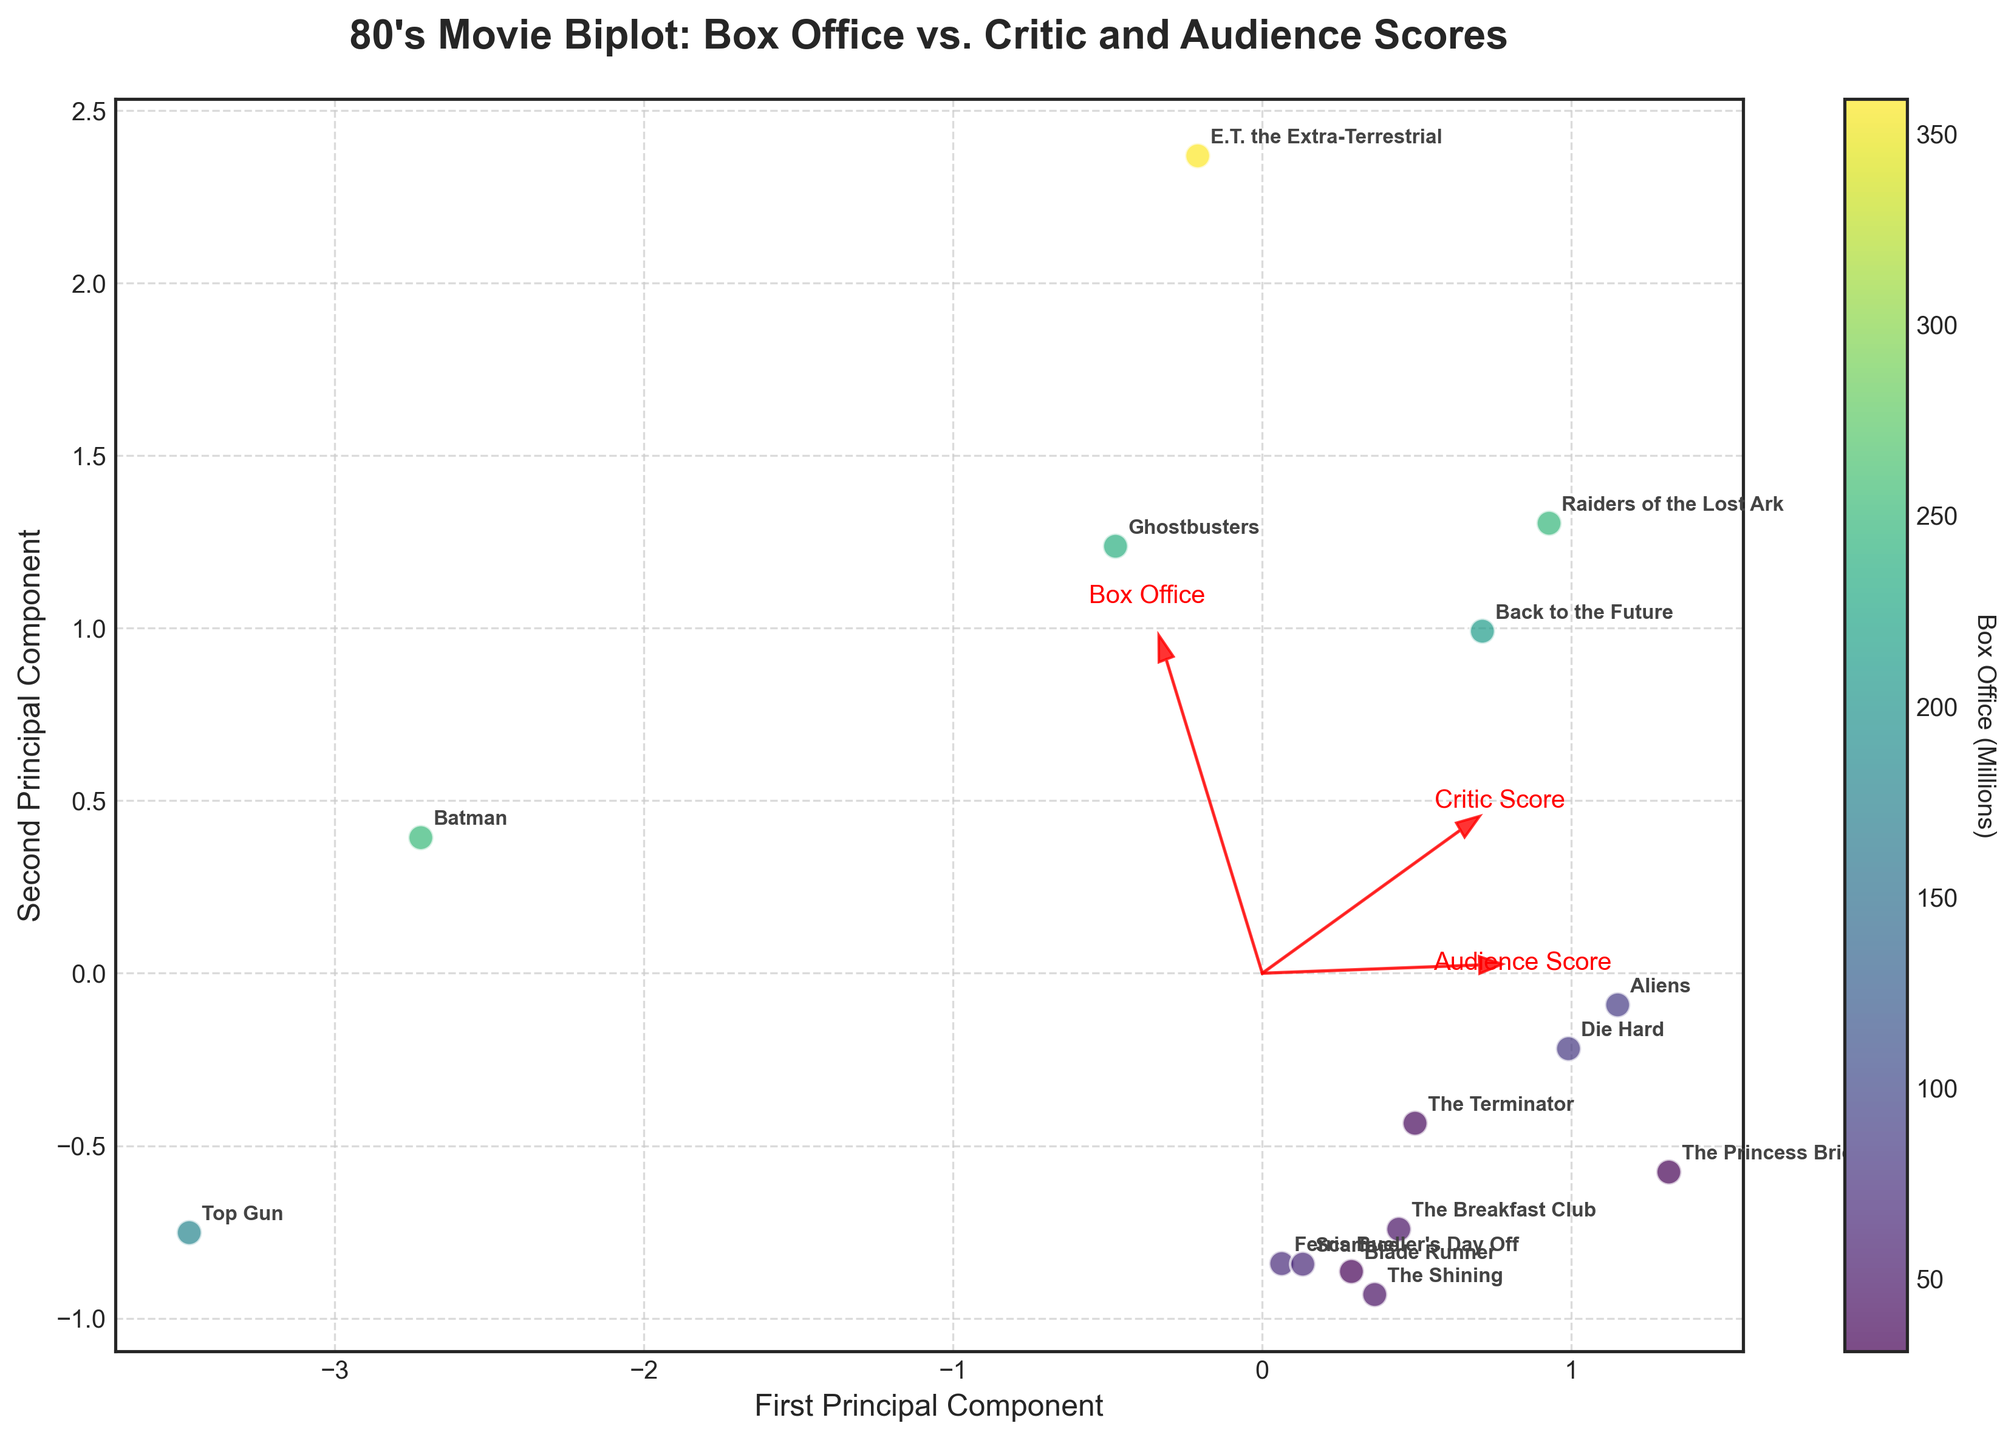What is the title of the plot? The title is usually placed at the top of the plot and gives a brief summary of what the plot represents. Here, the title is "80's Movie Biplot: Box Office vs. Critic and Audience Scores."
Answer: 80's Movie Biplot: Box Office vs. Critic and Audience Scores How many movies are displayed in the plot? To determine the number of movies displayed, count the number of distinct data points or annotations in the plot. Each movie has its name annotated next to it.
Answer: 15 Which movie has the highest box office performance? The color bar represents box office performance, with the highest values being closer to yellow. Look for the data point that is colored the most yellow.
Answer: E.T. the Extra-Terrestrial What are the labels for the x-axis and y-axis in this plot? Axis labels are usually placed next to the respective axis to indicate what each dimension represents. The plot's x-axis and y-axis labels are "First Principal Component" and "Second Principal Component."
Answer: First Principal Component, Second Principal Component Which feature vectors are shown in the plot? In a biplot, feature vectors are usually represented by arrows. The labels near the arrows indicate what each vector represents.
Answer: Box Office, Critic Score, Audience Score Which two movies have the closest PCA (Principal Component Analysis) scores? To answer this, look for the two data points that are closest to each other on the plot.
Answer: Blade Runner and The Terminator Which movie has the highest critic score, and where is it positioned relative to the origin of the plot? Critic Score can be inferred from the positioning concerning the corresponding feature vector. Look for the movie aligned with the vector and check its annotation.
Answer: The Terminator; positioned to the right of the origin How does "Raiders of the Lost Ark" perform compared to "Batman" in terms of box office performance? Compare the colors of the data points corresponding to "Raiders of the Lost Ark" and "Batman." The one closer to yellow has a higher box office performance.
Answer: Raiders of the Lost Ark has a higher box office performance Is there any movie positioned near the origin? Plots usually have an origin at (0,0), and if any data points are close to this, they could be considered near the origin. Check the plot for any points near the center.
Answer: No Which feature vector indicates a more substantial influence on the first principal component? Look at the length and direction of the feature vectors in relation to the first principal component (x-axis). The vector that aligns more closely with the x-axis shows a more substantial influence.
Answer: Box Office 